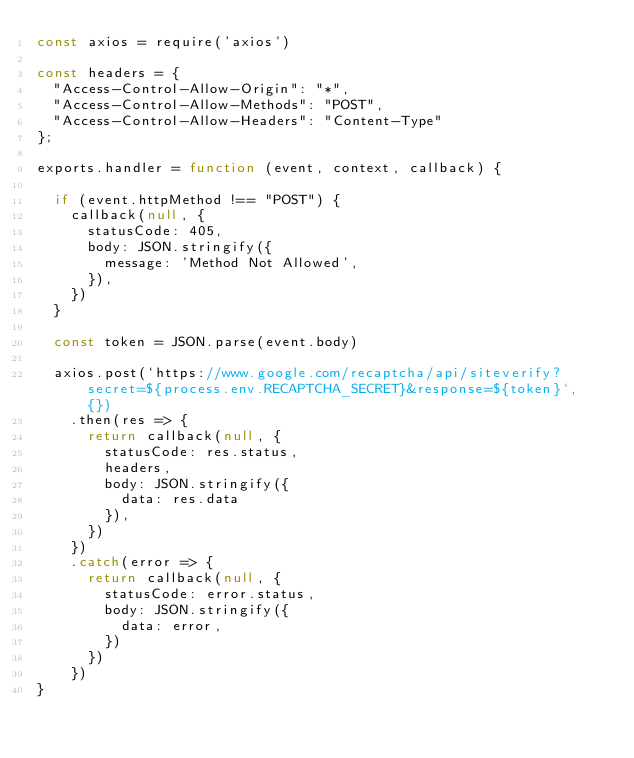<code> <loc_0><loc_0><loc_500><loc_500><_JavaScript_>const axios = require('axios')

const headers = {
  "Access-Control-Allow-Origin": "*",
  "Access-Control-Allow-Methods": "POST",
  "Access-Control-Allow-Headers": "Content-Type"
};

exports.handler = function (event, context, callback) {

  if (event.httpMethod !== "POST") {
    callback(null, {
      statusCode: 405,
      body: JSON.stringify({
        message: 'Method Not Allowed',
      }),
    })
  }

  const token = JSON.parse(event.body)

  axios.post(`https://www.google.com/recaptcha/api/siteverify?secret=${process.env.RECAPTCHA_SECRET}&response=${token}`, {})
    .then(res => {
      return callback(null, {
        statusCode: res.status,
        headers,
        body: JSON.stringify({
          data: res.data
        }),
      })
    })
    .catch(error => {
      return callback(null, {
        statusCode: error.status,
        body: JSON.stringify({
          data: error,
        })
      })
    })
}
</code> 